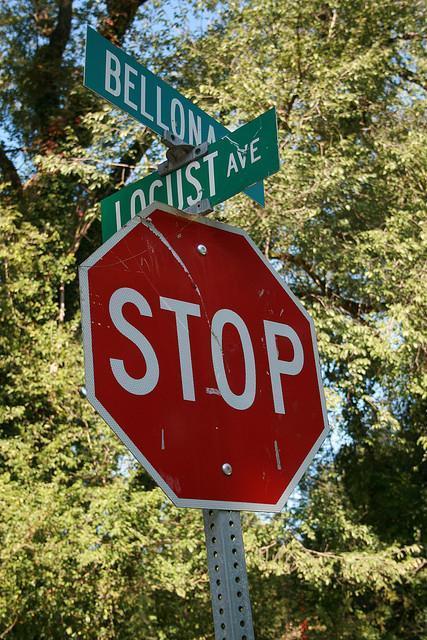How many sides does the STOP sign have?
Give a very brief answer. 8. 